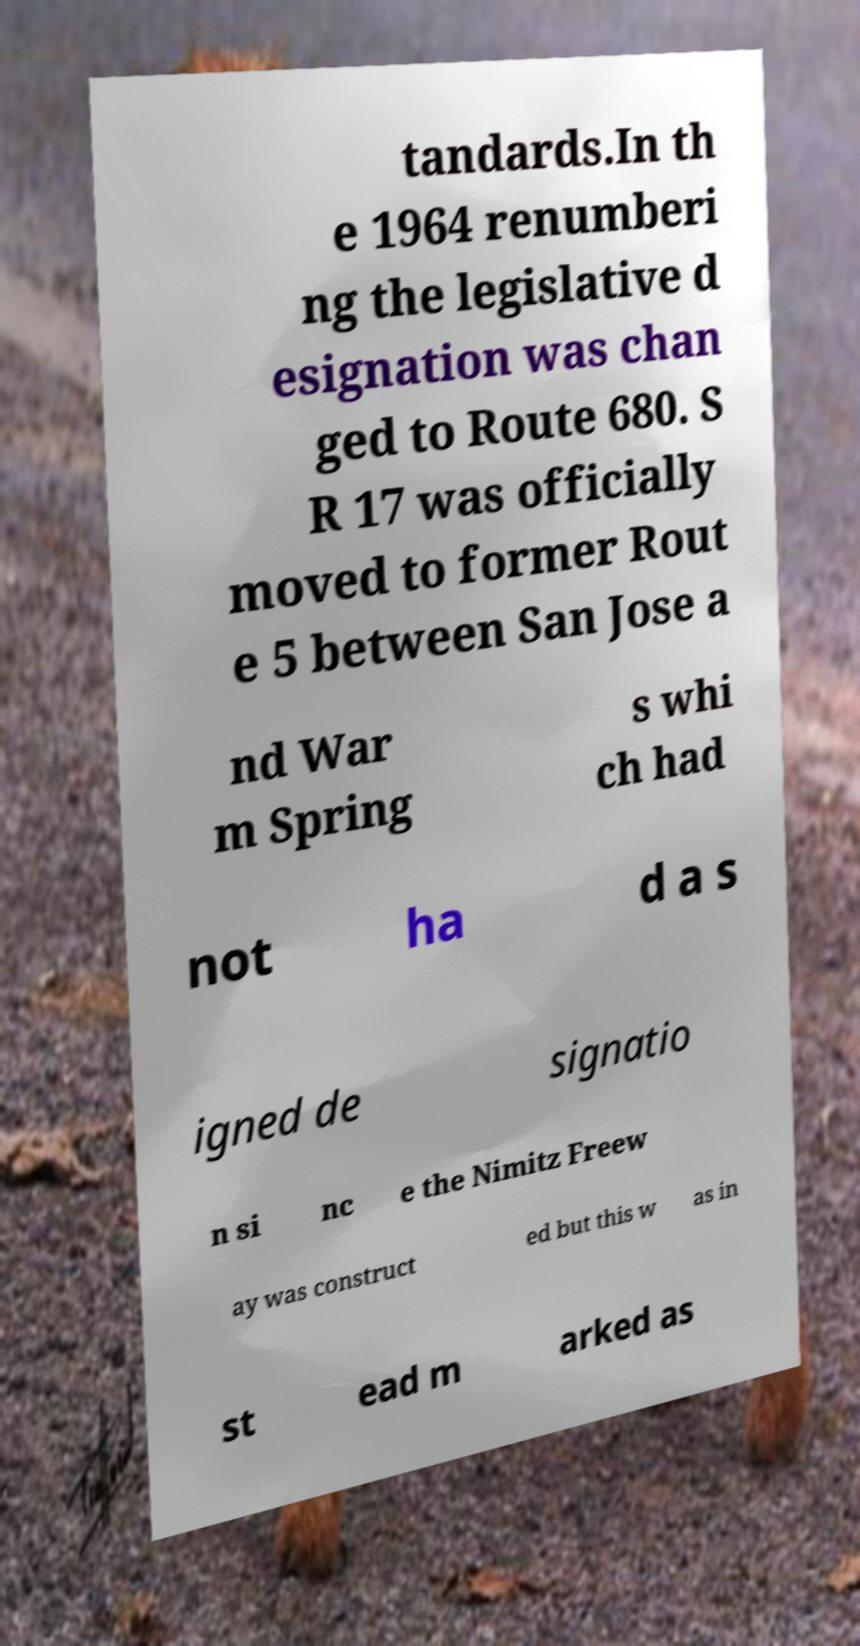Can you read and provide the text displayed in the image?This photo seems to have some interesting text. Can you extract and type it out for me? tandards.In th e 1964 renumberi ng the legislative d esignation was chan ged to Route 680. S R 17 was officially moved to former Rout e 5 between San Jose a nd War m Spring s whi ch had not ha d a s igned de signatio n si nc e the Nimitz Freew ay was construct ed but this w as in st ead m arked as 